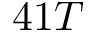<formula> <loc_0><loc_0><loc_500><loc_500>4 1 T</formula> 